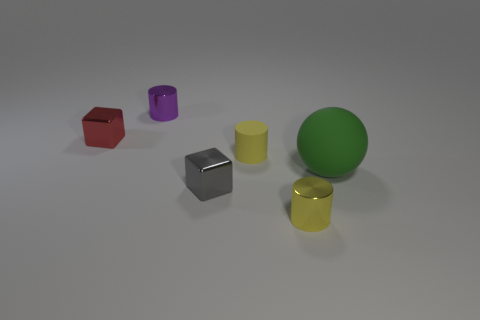Add 4 small green cylinders. How many objects exist? 10 Subtract all balls. How many objects are left? 5 Add 4 large cyan metal cylinders. How many large cyan metal cylinders exist? 4 Subtract 0 gray balls. How many objects are left? 6 Subtract all blue matte cylinders. Subtract all red objects. How many objects are left? 5 Add 2 yellow shiny objects. How many yellow shiny objects are left? 3 